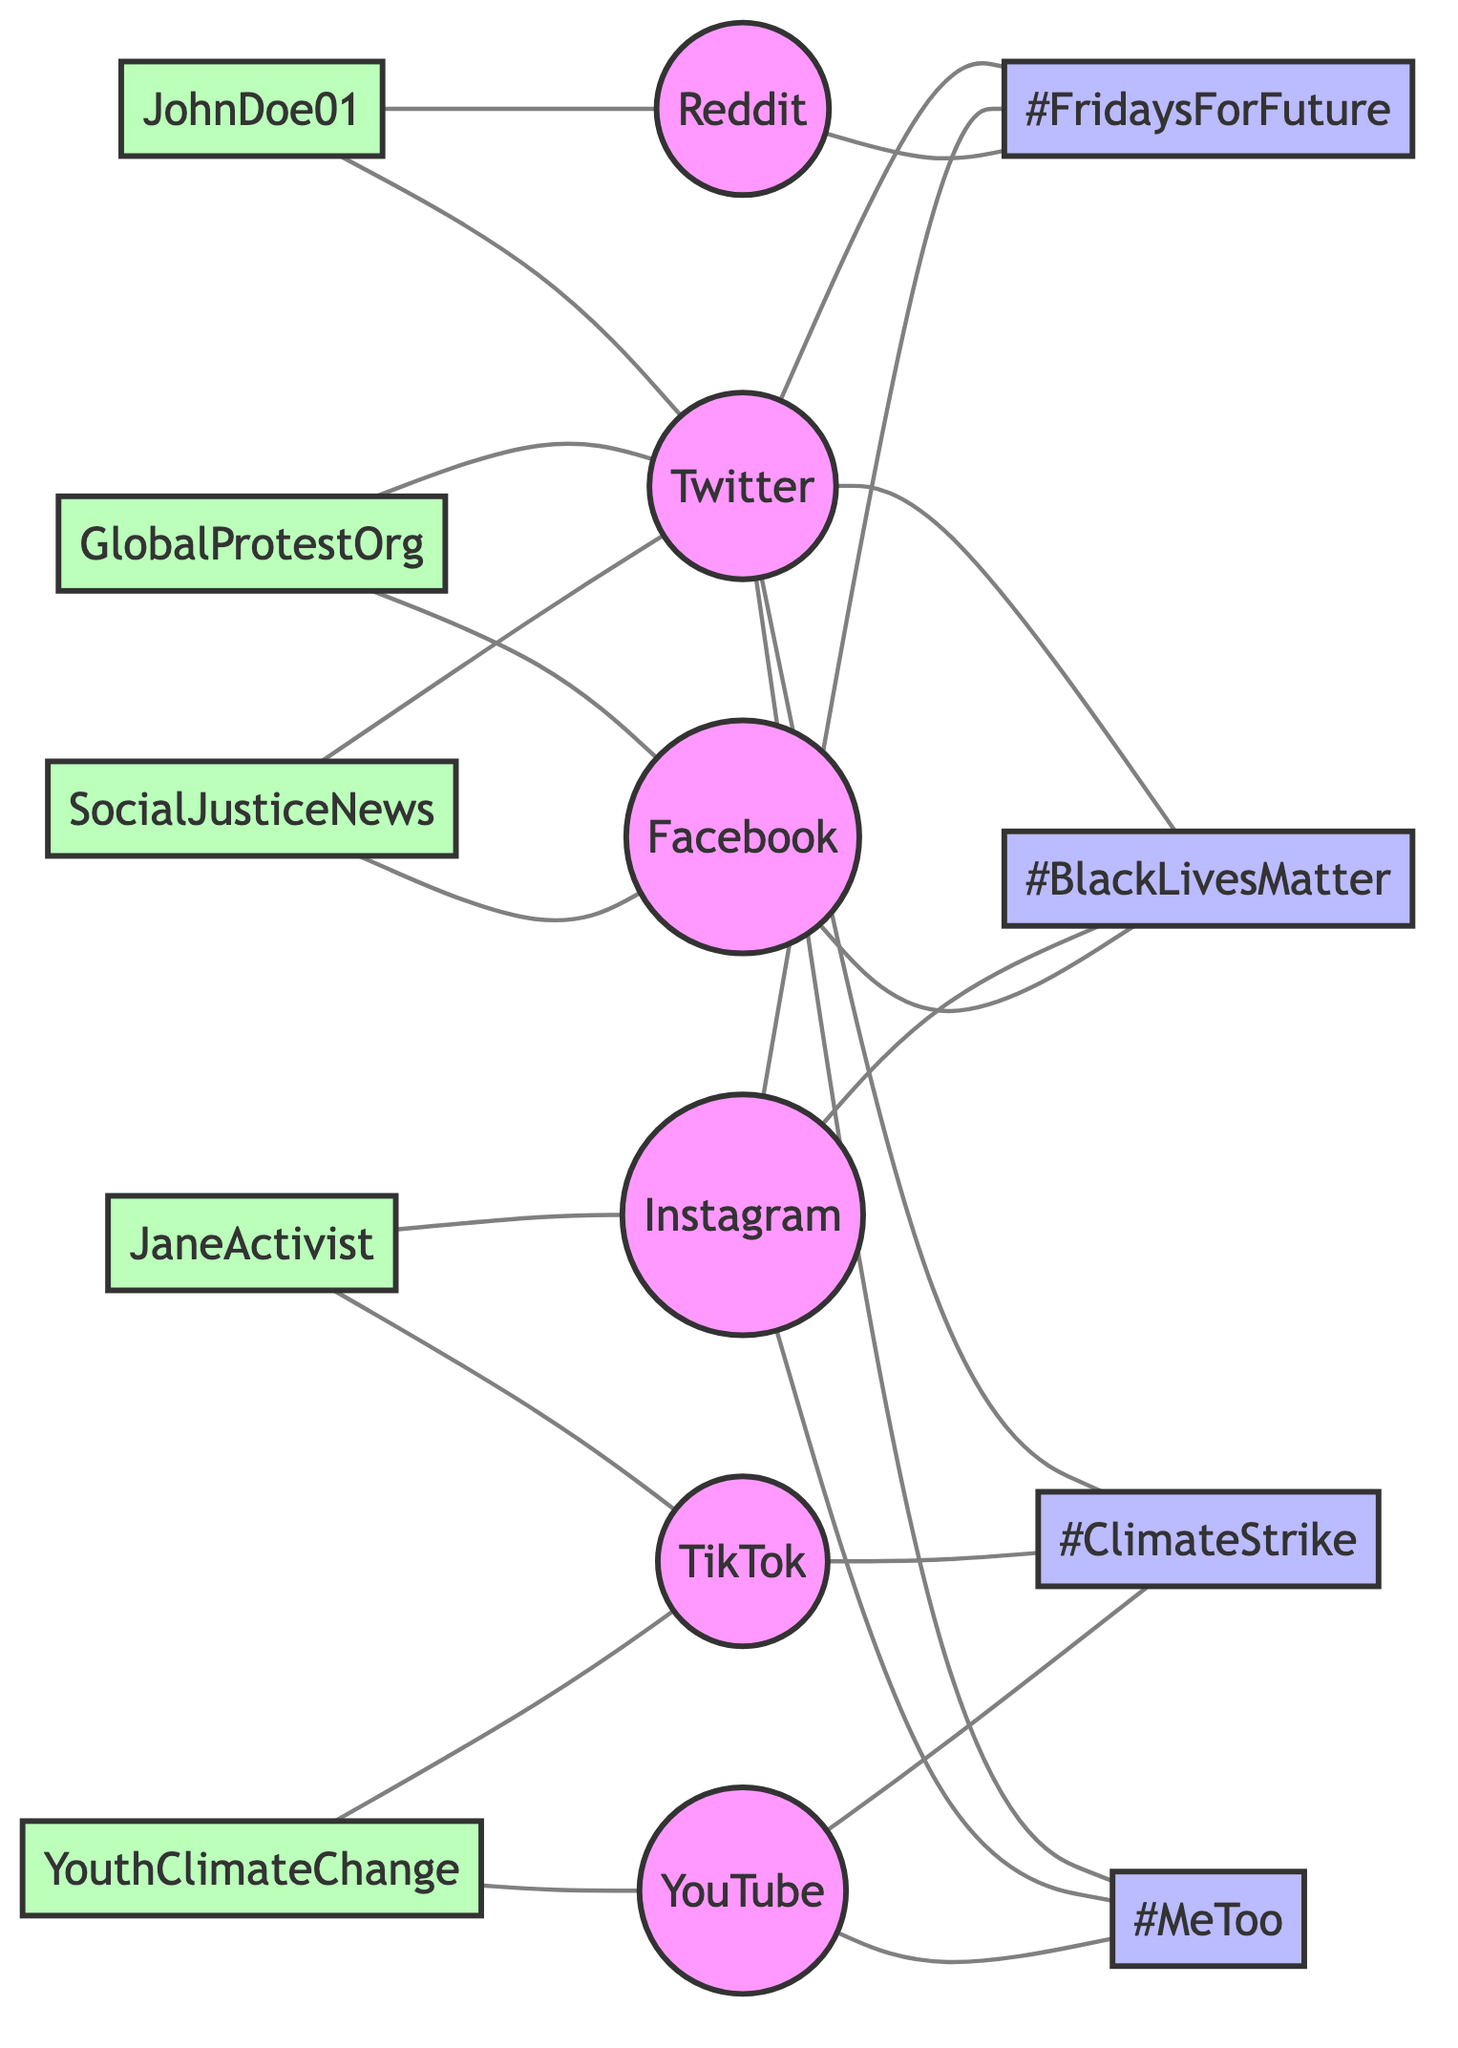What are the total number of nodes in the diagram? The diagram lists 15 distinct nodes as defined in the node data. They represent various social media platforms, protest hashtags, and user accounts.
Answer: 15 Which hashtag is connected to the most platforms? By examining the edges, #BlackLivesMatter, #MeToo, #ClimateStrike, and #FridaysForFuture are connected to social media platforms. #BlackLivesMatter is connected to Twitter, Facebook, and Instagram, making it the most connected with three connections.
Answer: #BlackLivesMatter How many edges are connected to Twitter? Counting the edges, Twitter has connections to #BlackLivesMatter, #MeToo, #ClimateStrike, #FridaysForFuture, as well as three user accounts (JohnDoe01, GlobalProtestOrg, SocialJusticeNews), resulting in a total of eight edges.
Answer: 8 Which hashtag has the fewest connections? Analyzing the connections, #FridaysForFuture is connected to Twitter, Instagram, and Reddit, making it tied with #MeToo (connected to Twitter, Instagram, and YouTube). Both hashtags have three connections each, but the question can specifically address #MeToo separately as having the fewest distinct connections.
Answer: #MeToo Which user is linked to both Twitter and Reddit? The data shows JohnDoe01 is connected to both Twitter and Reddit, as indicated in the edges. This connection highlights JohnDoe01's active role across these platforms.
Answer: JohnDoe01 How many unique social media platforms are represented in the diagram? The diagram lists six unique platforms: Twitter, Facebook, Instagram, TikTok, YouTube, and Reddit. By counting each instance individually, it is clear that there are no duplicates among the platform nodes.
Answer: 6 What is the relationship between the hashtag #ClimateStrike and TikTok? The edge directly links #ClimateStrike to TikTok, indicating that TikTok is one of the platforms where discussions or content related to #ClimateStrike are prevalent.
Answer: Direct connection Which user is associated with the hashtag #FridaysForFuture? By examining the edges, there's a direct connection from Instagram to #FridaysForFuture, indicating active engagement on that platform, but the user connection specifically associated with it is not directly determined within the edges.
Answer: None (no direct user) How many hashtags are present in the diagram? By reviewing the nodes defined as hashtags, there are four: #BlackLivesMatter, #ClimateStrike, #MeToo, and #FridaysForFuture, resulting in a straightforward count of these unique identifiers for social movements.
Answer: 4 